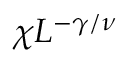Convert formula to latex. <formula><loc_0><loc_0><loc_500><loc_500>\chi L ^ { - \gamma / \nu }</formula> 